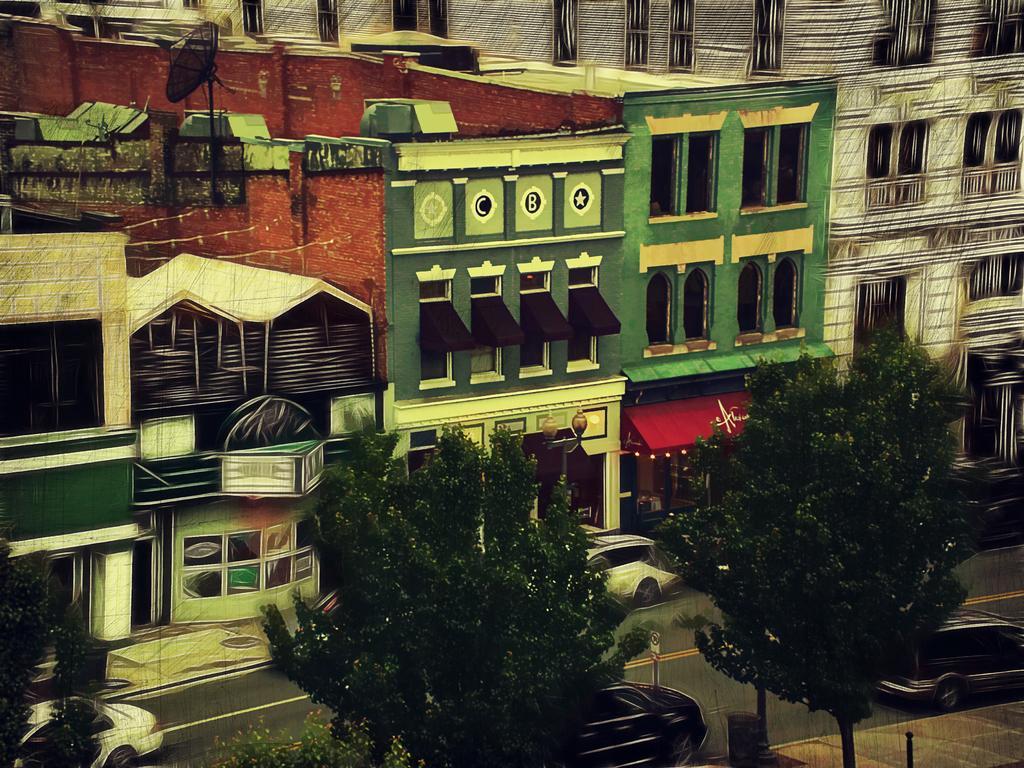Could you give a brief overview of what you see in this image? As we can see in the image, there are lot of buildings and there are three trees in the front. Beside the trees there is a road. On road there are three cars. 